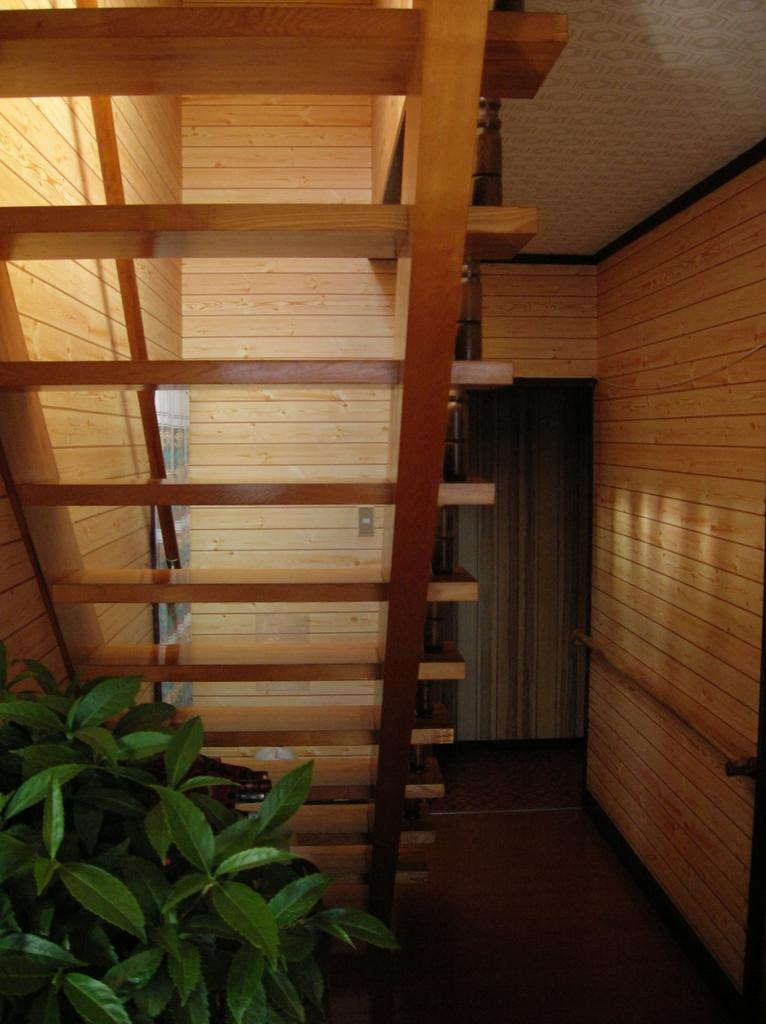What type of plant can be seen in the image? There is a houseplant in the image. What architectural feature is visible in the image? There is a staircase in the image. What type of surface is present in the image? There is a wall in the image. Where might this image have been taken? The image is likely taken in a house, given the presence of a houseplant and a staircase. What type of celery is being served in a bowl on the table in the image? There is no bowl or celery present in the image; it only features a houseplant, a staircase, and a wall. How is the oatmeal being prepared in the image? There is no oatmeal or preparation process visible in the image. 